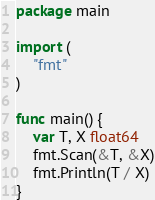Convert code to text. <code><loc_0><loc_0><loc_500><loc_500><_Go_>package main

import (
	"fmt"
)

func main() {
	var T, X float64
	fmt.Scan(&T, &X)
	fmt.Println(T / X)
}
</code> 